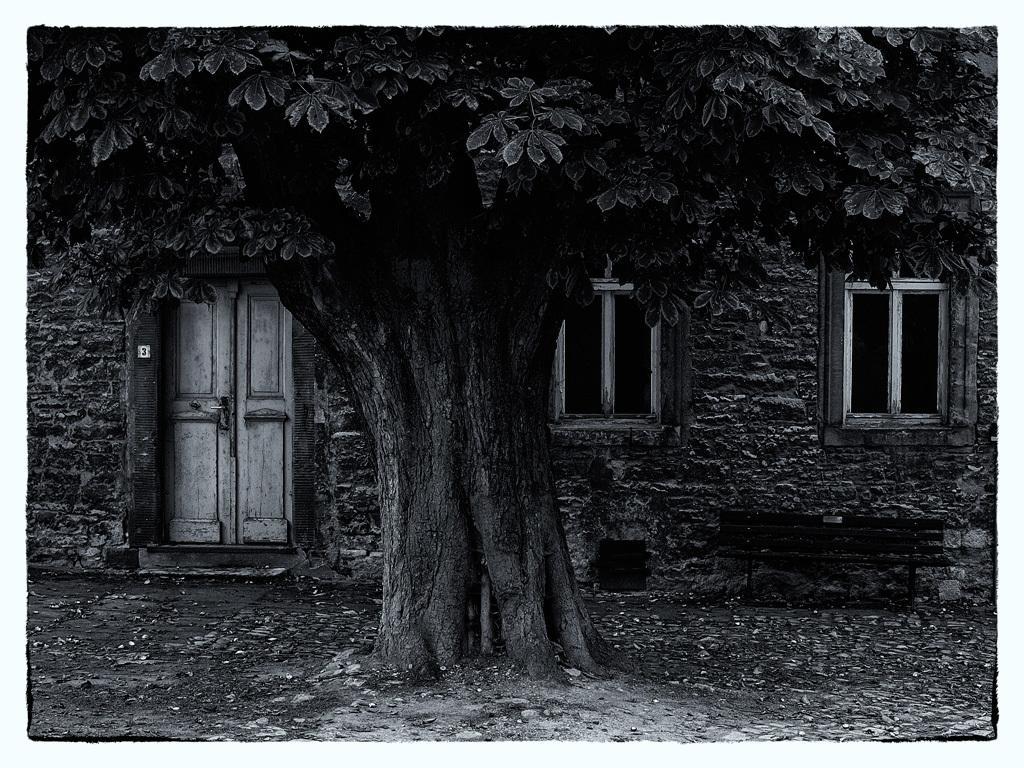How would you summarize this image in a sentence or two? This is a black and white image. In this image we can see a house with windows and a door. We can also see some stones on the ground, a container, a bench and a tree. 